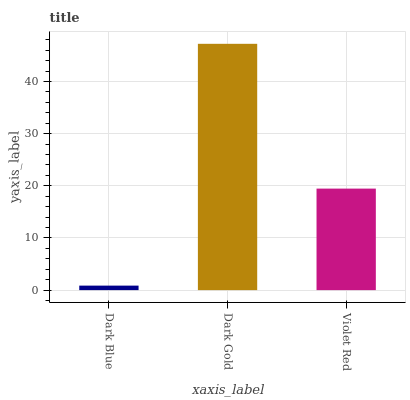Is Dark Blue the minimum?
Answer yes or no. Yes. Is Dark Gold the maximum?
Answer yes or no. Yes. Is Violet Red the minimum?
Answer yes or no. No. Is Violet Red the maximum?
Answer yes or no. No. Is Dark Gold greater than Violet Red?
Answer yes or no. Yes. Is Violet Red less than Dark Gold?
Answer yes or no. Yes. Is Violet Red greater than Dark Gold?
Answer yes or no. No. Is Dark Gold less than Violet Red?
Answer yes or no. No. Is Violet Red the high median?
Answer yes or no. Yes. Is Violet Red the low median?
Answer yes or no. Yes. Is Dark Gold the high median?
Answer yes or no. No. Is Dark Gold the low median?
Answer yes or no. No. 